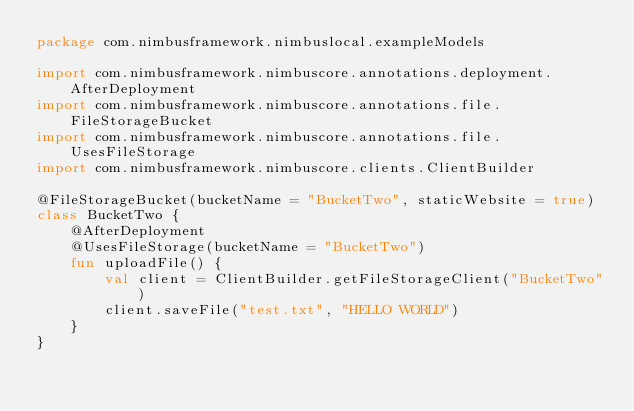<code> <loc_0><loc_0><loc_500><loc_500><_Kotlin_>package com.nimbusframework.nimbuslocal.exampleModels

import com.nimbusframework.nimbuscore.annotations.deployment.AfterDeployment
import com.nimbusframework.nimbuscore.annotations.file.FileStorageBucket
import com.nimbusframework.nimbuscore.annotations.file.UsesFileStorage
import com.nimbusframework.nimbuscore.clients.ClientBuilder

@FileStorageBucket(bucketName = "BucketTwo", staticWebsite = true)
class BucketTwo {
    @AfterDeployment
    @UsesFileStorage(bucketName = "BucketTwo")
    fun uploadFile() {
        val client = ClientBuilder.getFileStorageClient("BucketTwo")
        client.saveFile("test.txt", "HELLO WORLD")
    }
}</code> 